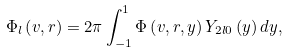Convert formula to latex. <formula><loc_0><loc_0><loc_500><loc_500>\Phi _ { l } \left ( v , r \right ) = 2 \pi \int ^ { 1 } _ { - 1 } \Phi \left ( v , r , y \right ) Y _ { 2 l 0 } \left ( y \right ) d y ,</formula> 